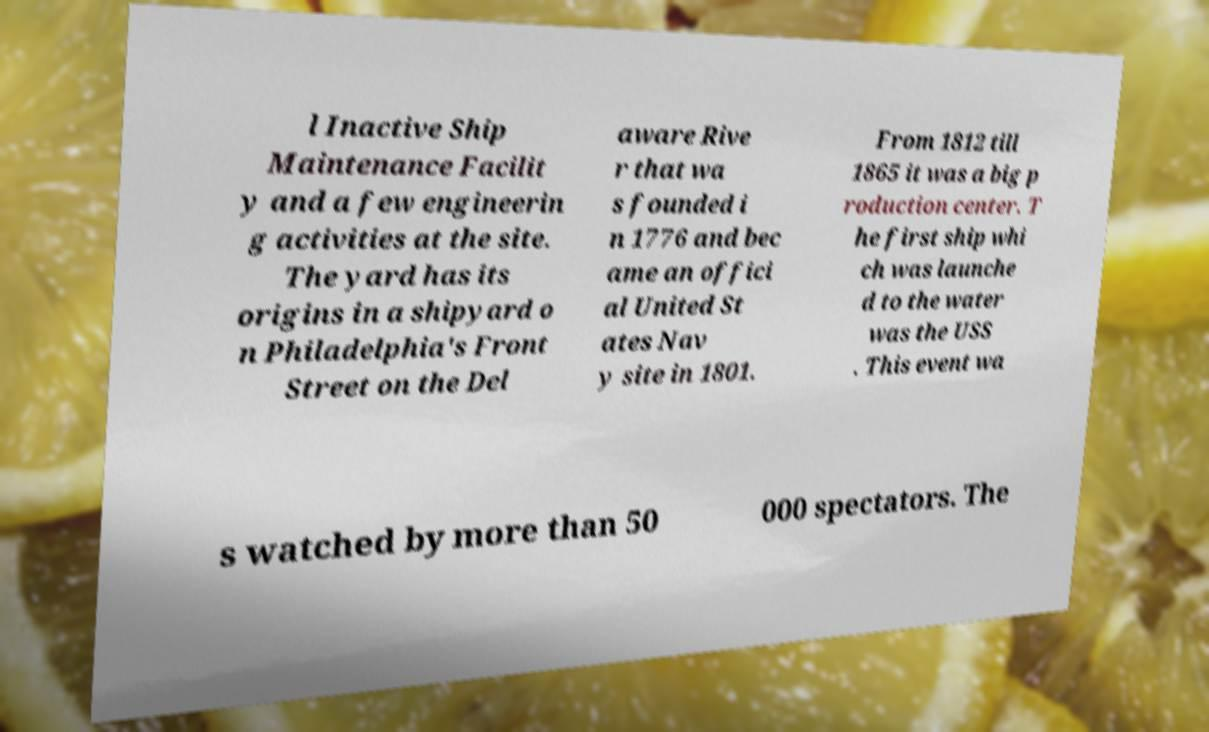Could you extract and type out the text from this image? l Inactive Ship Maintenance Facilit y and a few engineerin g activities at the site. The yard has its origins in a shipyard o n Philadelphia's Front Street on the Del aware Rive r that wa s founded i n 1776 and bec ame an offici al United St ates Nav y site in 1801. From 1812 till 1865 it was a big p roduction center. T he first ship whi ch was launche d to the water was the USS . This event wa s watched by more than 50 000 spectators. The 